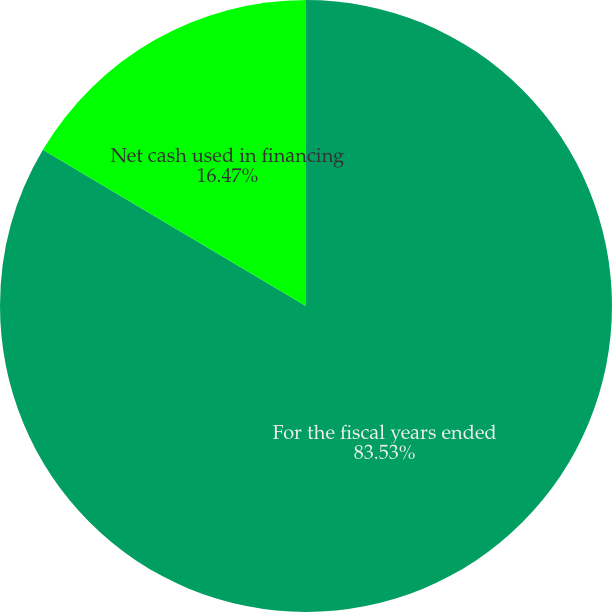Convert chart to OTSL. <chart><loc_0><loc_0><loc_500><loc_500><pie_chart><fcel>For the fiscal years ended<fcel>Net cash used in financing<nl><fcel>83.53%<fcel>16.47%<nl></chart> 